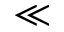<formula> <loc_0><loc_0><loc_500><loc_500>\ll</formula> 